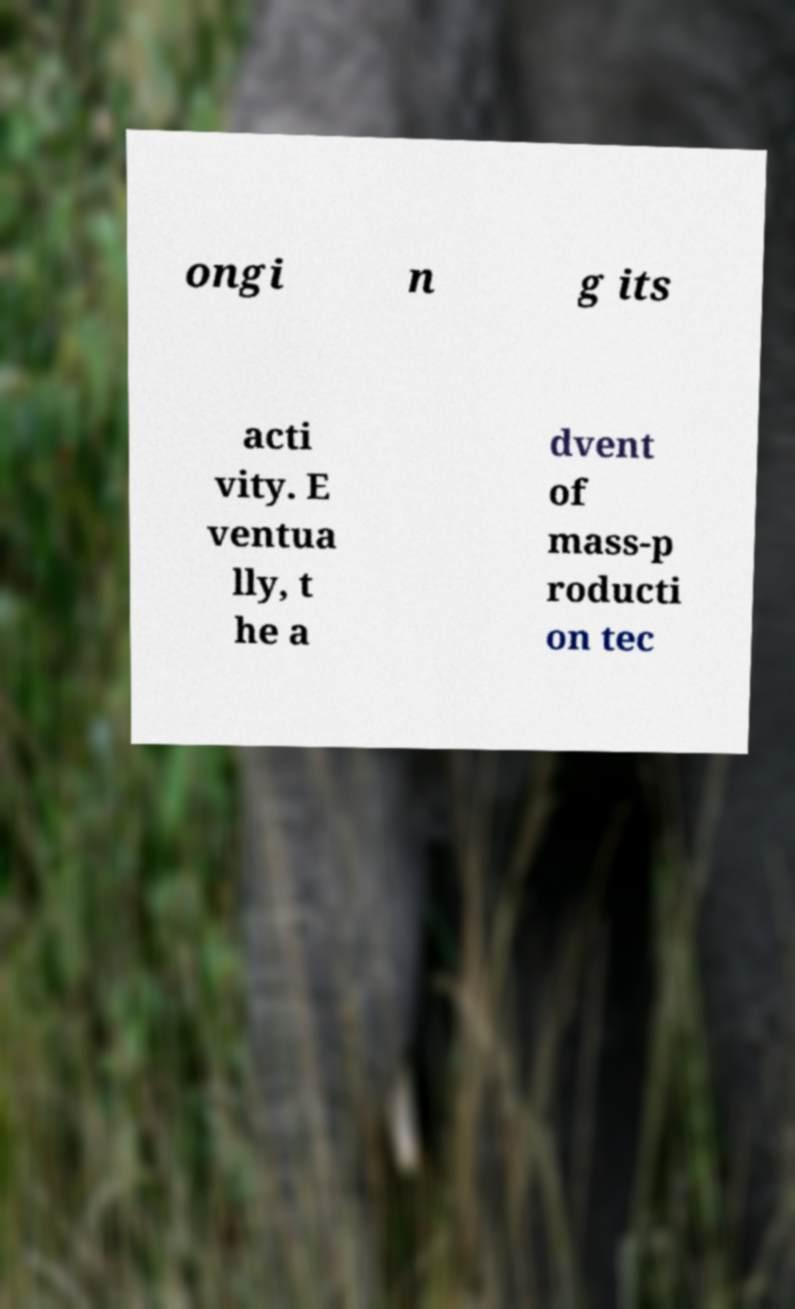Can you accurately transcribe the text from the provided image for me? ongi n g its acti vity. E ventua lly, t he a dvent of mass-p roducti on tec 